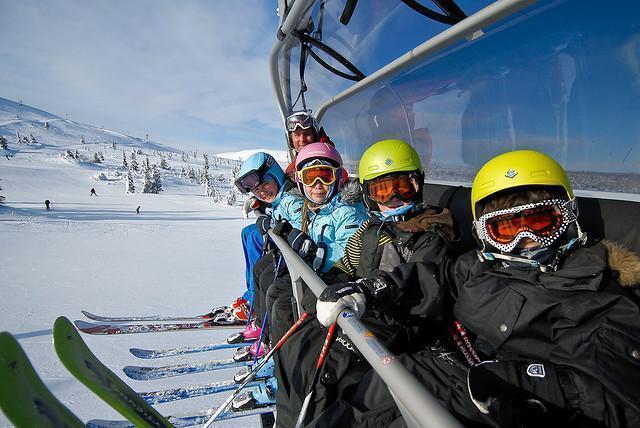Which course are the people on the lift probably being brought to?
Select the accurate answer and provide explanation: 'Answer: answer
Rationale: rationale.'
Options: Professional, beginner, advanced, dare devil. Answer: beginner.
Rationale: They are children so they would not have had enough time to have had more experience. 